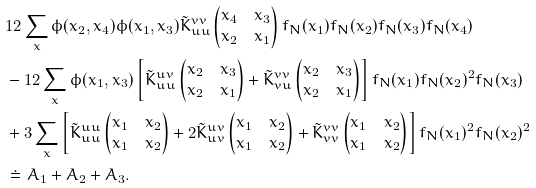Convert formula to latex. <formula><loc_0><loc_0><loc_500><loc_500>& 1 2 \sum _ { x } \phi ( x _ { 2 } , x _ { 4 } ) \phi ( x _ { 1 } , x _ { 3 } ) \tilde { K } _ { u u } ^ { v v } \left ( \begin{matrix} x _ { 4 } & x _ { 3 } \\ x _ { 2 } & x _ { 1 } \end{matrix} \right ) f _ { N } ( x _ { 1 } ) f _ { N } ( x _ { 2 } ) f _ { N } ( x _ { 3 } ) f _ { N } ( x _ { 4 } ) \\ & - 1 2 \sum _ { x } \phi ( x _ { 1 } , x _ { 3 } ) \left [ \tilde { K } _ { u u } ^ { u v } \left ( \begin{matrix} x _ { 2 } & x _ { 3 } \\ x _ { 2 } & x _ { 1 } \end{matrix} \right ) + \tilde { K } _ { v u } ^ { v v } \left ( \begin{matrix} x _ { 2 } & x _ { 3 } \\ x _ { 2 } & x _ { 1 } \end{matrix} \right ) \right ] f _ { N } ( x _ { 1 } ) f _ { N } ( x _ { 2 } ) ^ { 2 } f _ { N } ( x _ { 3 } ) \\ & + 3 \sum _ { x } \left [ \tilde { K } _ { u u } ^ { u u } \left ( \begin{matrix} x _ { 1 } & x _ { 2 } \\ x _ { 1 } & x _ { 2 } \end{matrix} \right ) + 2 \tilde { K } _ { u v } ^ { u v } \left ( \begin{matrix} x _ { 1 } & x _ { 2 } \\ x _ { 1 } & x _ { 2 } \end{matrix} \right ) + \tilde { K } _ { v v } ^ { v v } \left ( \begin{matrix} x _ { 1 } & x _ { 2 } \\ x _ { 1 } & x _ { 2 } \end{matrix} \right ) \right ] f _ { N } ( x _ { 1 } ) ^ { 2 } f _ { N } ( x _ { 2 } ) ^ { 2 } \\ & \doteq A _ { 1 } + A _ { 2 } + A _ { 3 } .</formula> 